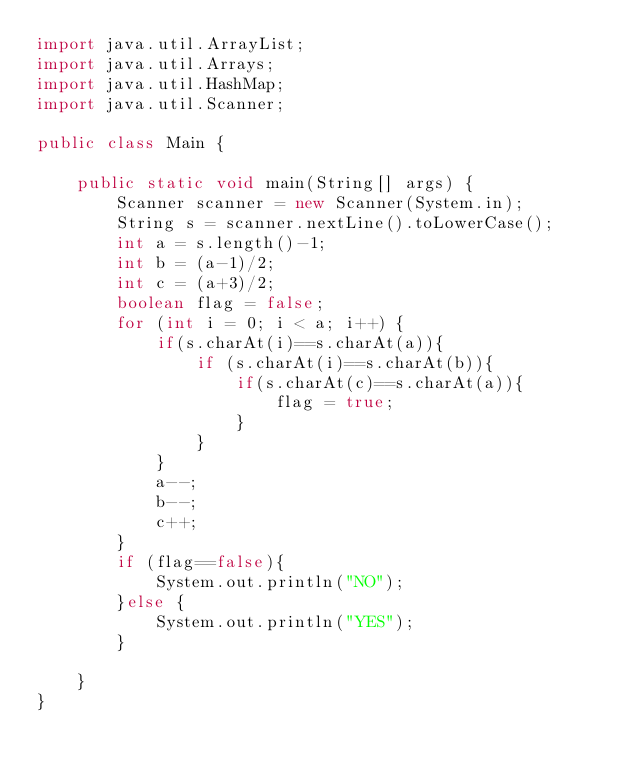<code> <loc_0><loc_0><loc_500><loc_500><_Java_>import java.util.ArrayList;
import java.util.Arrays;
import java.util.HashMap;
import java.util.Scanner;

public class Main {

    public static void main(String[] args) {
        Scanner scanner = new Scanner(System.in);
        String s = scanner.nextLine().toLowerCase();
        int a = s.length()-1;
        int b = (a-1)/2;
        int c = (a+3)/2;
        boolean flag = false;
        for (int i = 0; i < a; i++) {
            if(s.charAt(i)==s.charAt(a)){
                if (s.charAt(i)==s.charAt(b)){
                    if(s.charAt(c)==s.charAt(a)){
                        flag = true;
                    }
                }
            }
            a--;
            b--;
            c++;
        }
        if (flag==false){
            System.out.println("NO");
        }else {
            System.out.println("YES");
        }

    }
}
</code> 